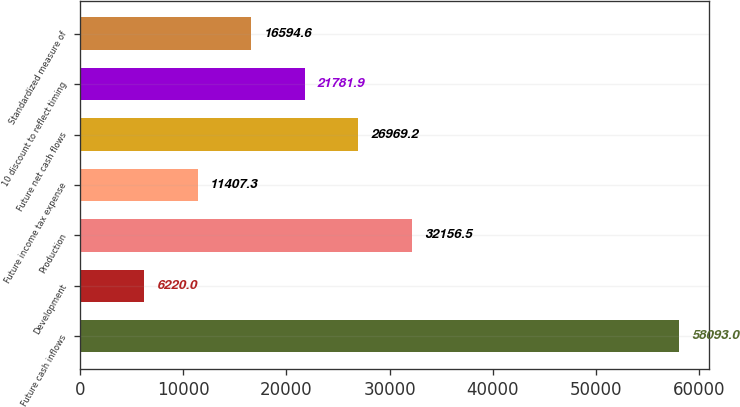<chart> <loc_0><loc_0><loc_500><loc_500><bar_chart><fcel>Future cash inflows<fcel>Development<fcel>Production<fcel>Future income tax expense<fcel>Future net cash flows<fcel>10 discount to reflect timing<fcel>Standardized measure of<nl><fcel>58093<fcel>6220<fcel>32156.5<fcel>11407.3<fcel>26969.2<fcel>21781.9<fcel>16594.6<nl></chart> 